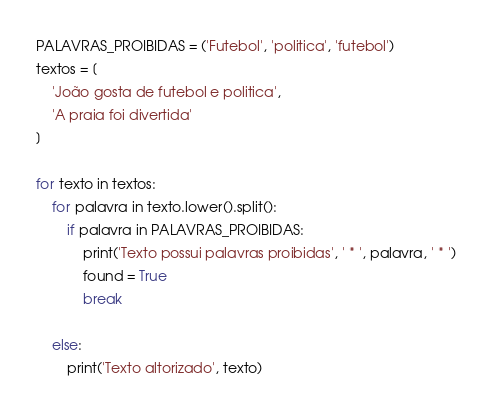Convert code to text. <code><loc_0><loc_0><loc_500><loc_500><_Python_>PALAVRAS_PROIBIDAS = ('Futebol', 'politica', 'futebol')
textos = [
    'João gosta de futebol e politica',
    'A praia foi divertida'
]

for texto in textos:
    for palavra in texto.lower().split():
        if palavra in PALAVRAS_PROIBIDAS:
            print('Texto possui palavras proibidas', ' * ', palavra, ' * ')
            found = True
            break

    else:
        print('Texto altorizado', texto)
</code> 